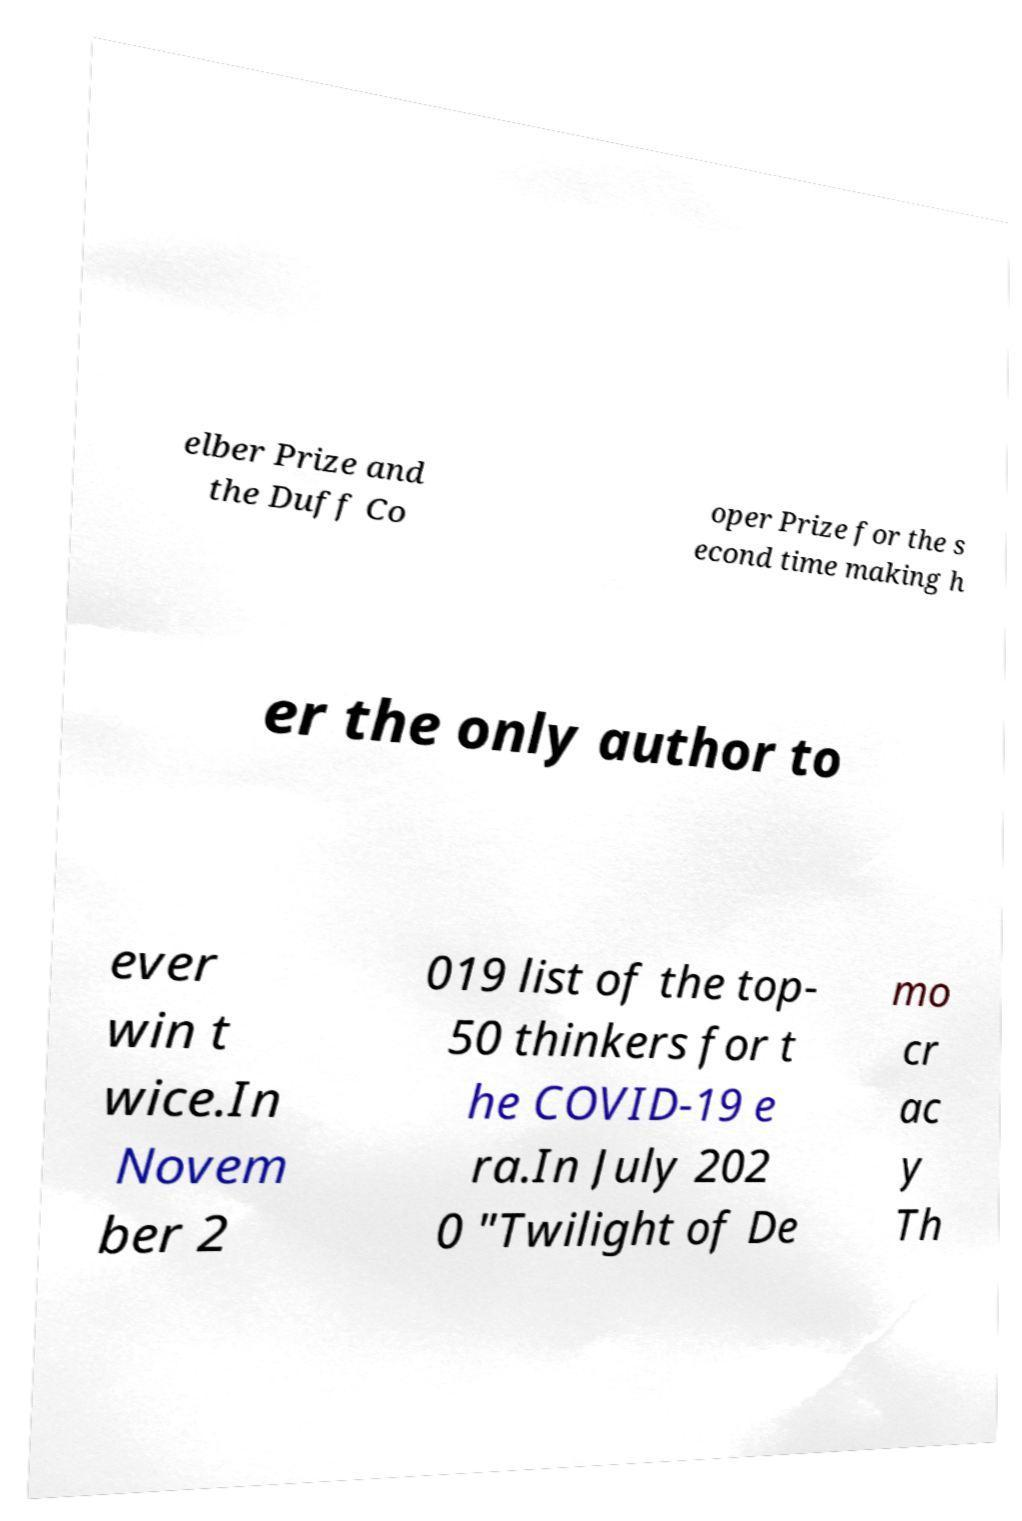For documentation purposes, I need the text within this image transcribed. Could you provide that? elber Prize and the Duff Co oper Prize for the s econd time making h er the only author to ever win t wice.In Novem ber 2 019 list of the top- 50 thinkers for t he COVID-19 e ra.In July 202 0 "Twilight of De mo cr ac y Th 